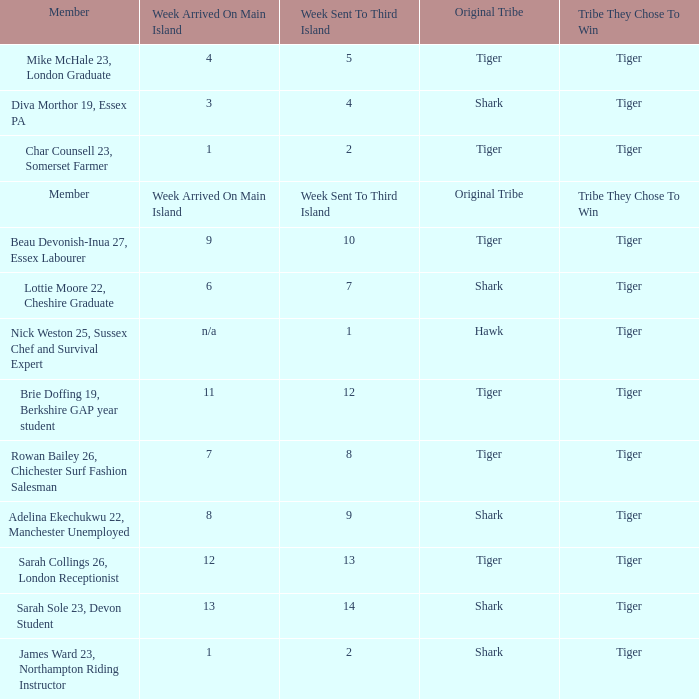What week was the member who arrived on the main island in week 6 sent to the third island? 7.0. Could you help me parse every detail presented in this table? {'header': ['Member', 'Week Arrived On Main Island', 'Week Sent To Third Island', 'Original Tribe', 'Tribe They Chose To Win'], 'rows': [['Mike McHale 23, London Graduate', '4', '5', 'Tiger', 'Tiger'], ['Diva Morthor 19, Essex PA', '3', '4', 'Shark', 'Tiger'], ['Char Counsell 23, Somerset Farmer', '1', '2', 'Tiger', 'Tiger'], ['Member', 'Week Arrived On Main Island', 'Week Sent To Third Island', 'Original Tribe', 'Tribe They Chose To Win'], ['Beau Devonish-Inua 27, Essex Labourer', '9', '10', 'Tiger', 'Tiger'], ['Lottie Moore 22, Cheshire Graduate', '6', '7', 'Shark', 'Tiger'], ['Nick Weston 25, Sussex Chef and Survival Expert', 'n/a', '1', 'Hawk', 'Tiger'], ['Brie Doffing 19, Berkshire GAP year student', '11', '12', 'Tiger', 'Tiger'], ['Rowan Bailey 26, Chichester Surf Fashion Salesman', '7', '8', 'Tiger', 'Tiger'], ['Adelina Ekechukwu 22, Manchester Unemployed', '8', '9', 'Shark', 'Tiger'], ['Sarah Collings 26, London Receptionist', '12', '13', 'Tiger', 'Tiger'], ['Sarah Sole 23, Devon Student', '13', '14', 'Shark', 'Tiger'], ['James Ward 23, Northampton Riding Instructor', '1', '2', 'Shark', 'Tiger']]} 